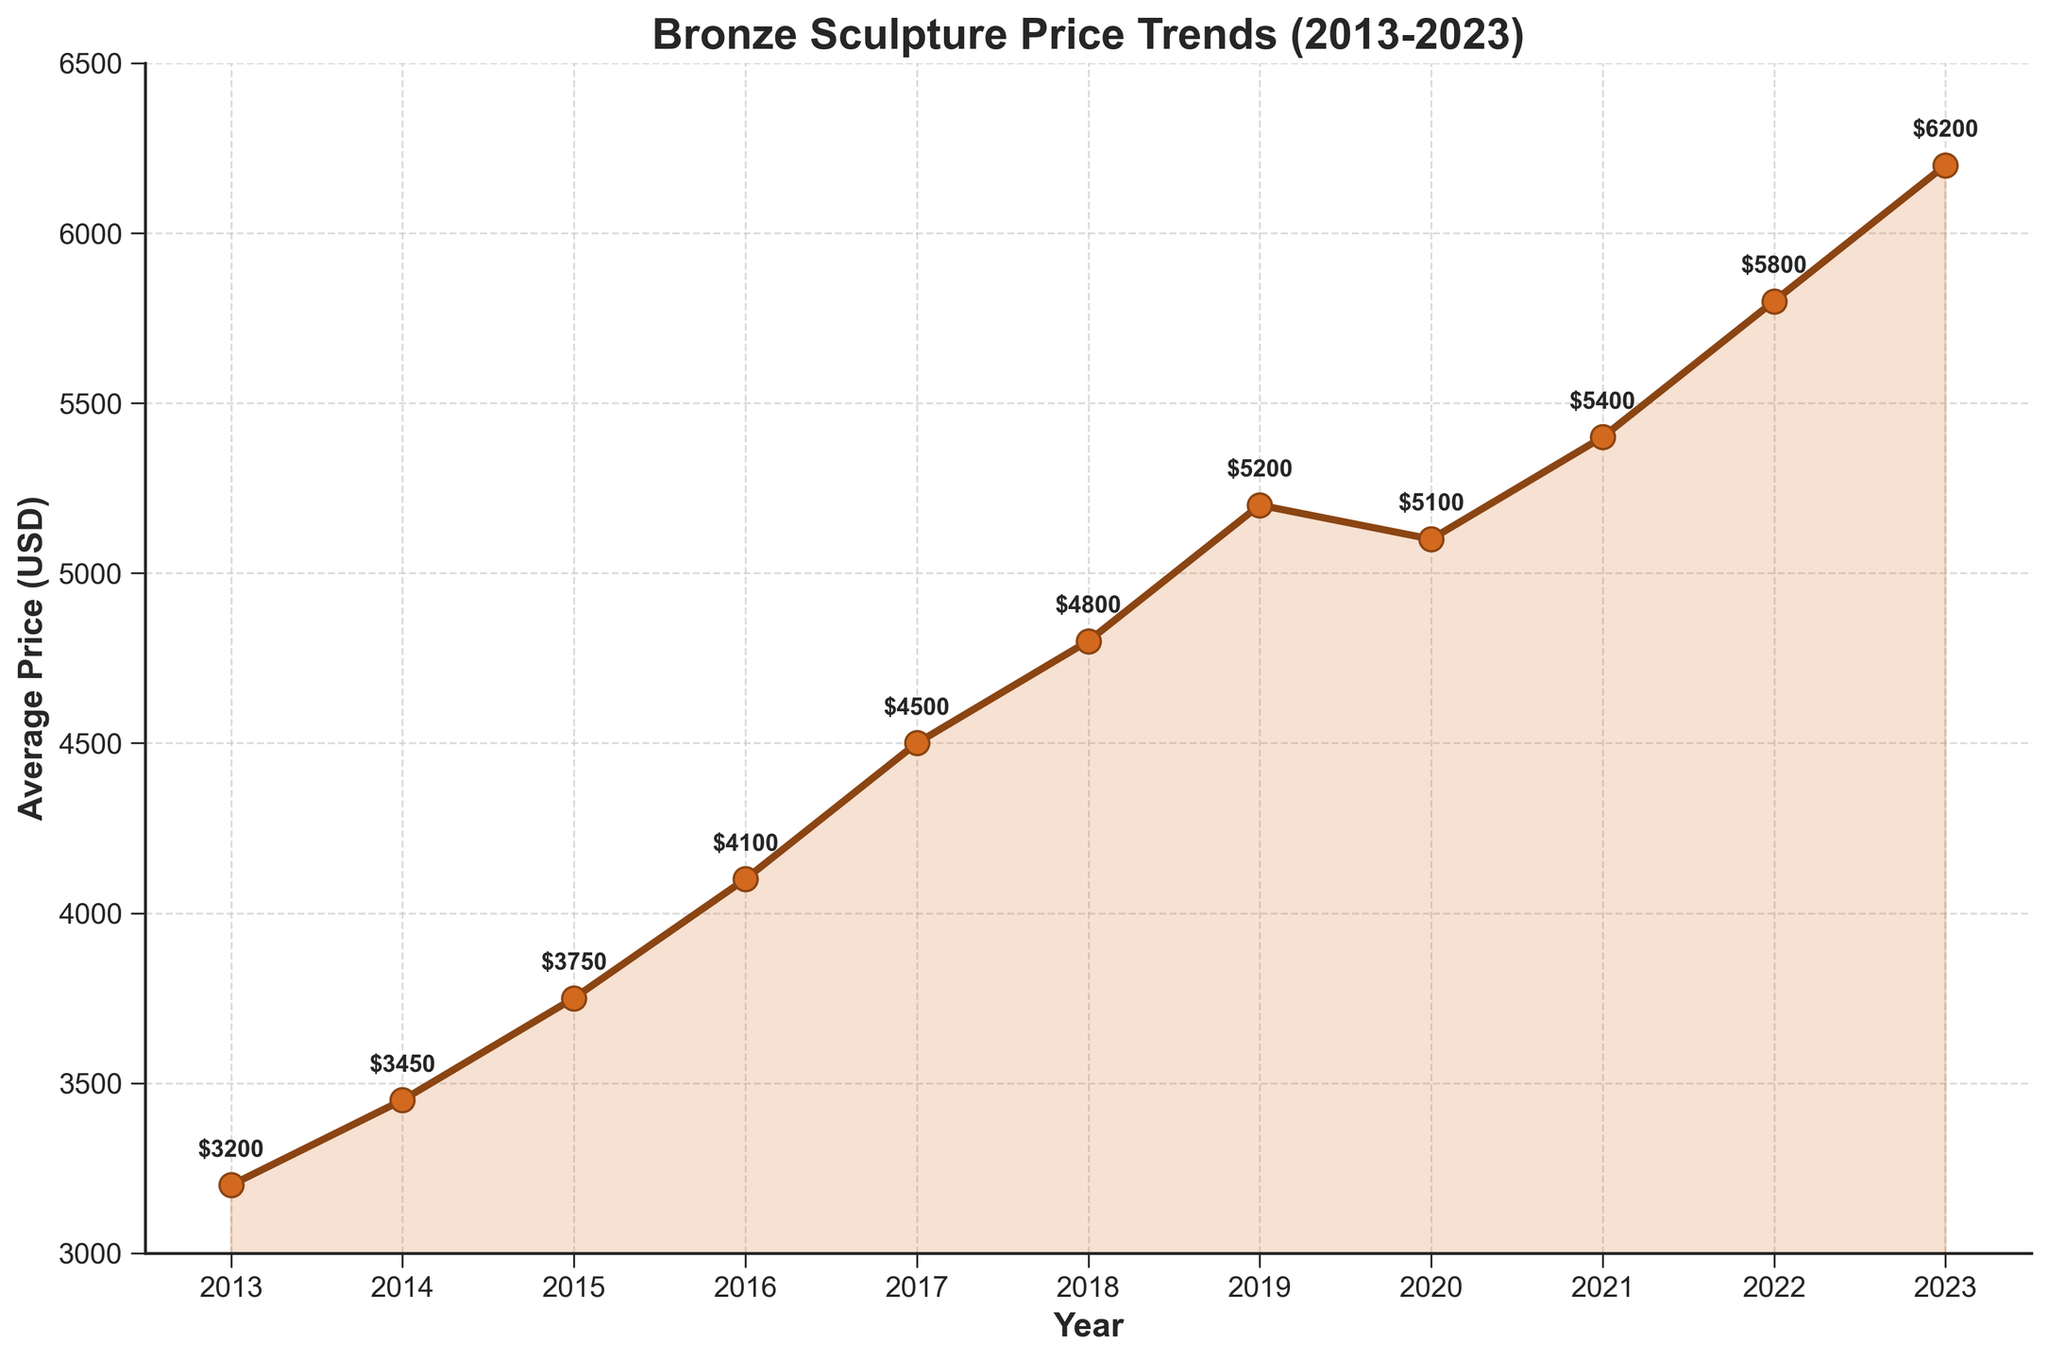What was the average price of bronze sculptures in 2013? The figure shows a point labeled with the price for each year. The label for 2013 shows $3200.
Answer: $3200 Which year had the highest average price? By looking at the values on the y-axis, the highest point on the chart is in 2023, labeled as $6200.
Answer: 2023 How much did the average price increase from 2013 to 2023? The average price in 2013 was $3200 and in 2023 it was $6200. The difference is calculated as $6200 - $3200.
Answer: $3000 What is the percentage increase in average price from 2013 to 2023? The price in 2013 was $3200, and in 2023 it was $6200. The percentage increase is calculated by $\frac{6200-3200}{3200} \times 100$.
Answer: 93.75% Which year experienced a decline in average price compared to the previous year? Observing the chart, the only year where the price decreases is from 2019 to 2020, from $5200 to $5100.
Answer: 2020 What is the average price over the entire period from 2013 to 2023? Sum all the yearly average prices and divide by the number of years (11): (3200 + 3450 + 3750 + 4100 + 4500 + 4800 + 5200 + 5100 + 5400 + 5800 + 6200) / 11.
Answer: $4575.45 In which year did the average price increase the most compared to the previous year? By checking the difference between consecutive years, the largest increase occurs between 2016 ($4100) and 2017 ($4500), which is $4500 - $4100.
Answer: 2017 What is the difference between the average price in 2018 and 2015? The price in 2018 is $4800 and in 2015 it is $3750. The difference is $4800 - $3750.
Answer: $1050 In which year did the average price first exceed $5000? Observing the chart, the average price first exceeds $5000 in 2019 ($5200).
Answer: 2019 What is the average annual increase in price between 2013 and 2023? The total increase over this period is $6200-$3200 = $3000. There are 10 intervals between 2013 and 2023, so the average annual increase is $3000/10.
Answer: $300 